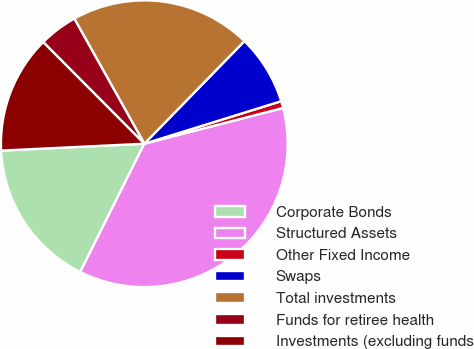<chart> <loc_0><loc_0><loc_500><loc_500><pie_chart><fcel>Corporate Bonds<fcel>Structured Assets<fcel>Other Fixed Income<fcel>Swaps<fcel>Total investments<fcel>Funds for retiree health<fcel>Investments (excluding funds<nl><fcel>16.86%<fcel>36.38%<fcel>0.78%<fcel>7.9%<fcel>20.42%<fcel>4.34%<fcel>13.3%<nl></chart> 